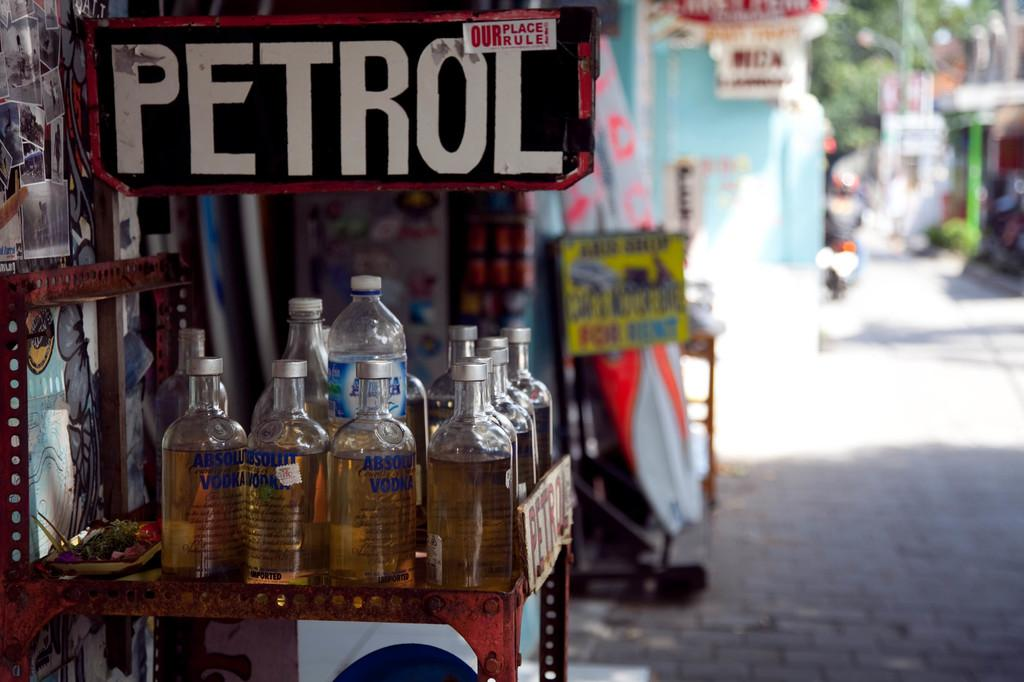<image>
Write a terse but informative summary of the picture. bottles of absolut vodka on a rack outside under a petrol sign 